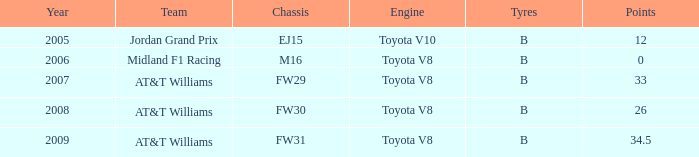What is the low point total after 2006 with an m16 chassis? None. 